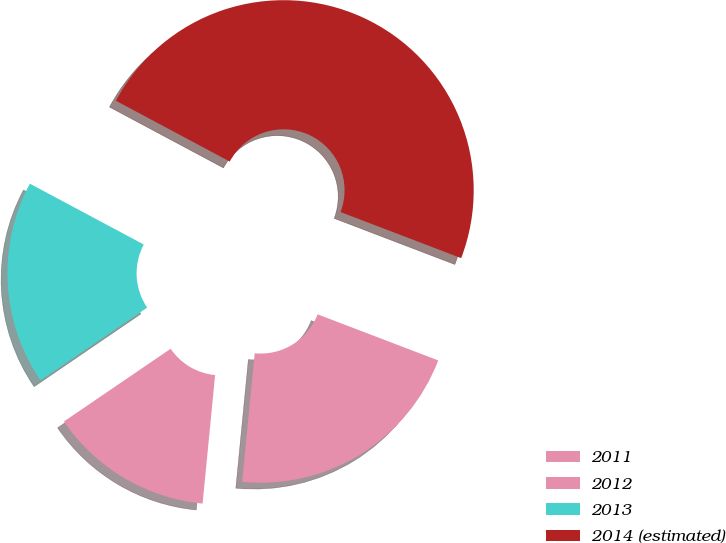Convert chart to OTSL. <chart><loc_0><loc_0><loc_500><loc_500><pie_chart><fcel>2011<fcel>2012<fcel>2013<fcel>2014 (estimated)<nl><fcel>20.74%<fcel>13.93%<fcel>17.33%<fcel>48.0%<nl></chart> 